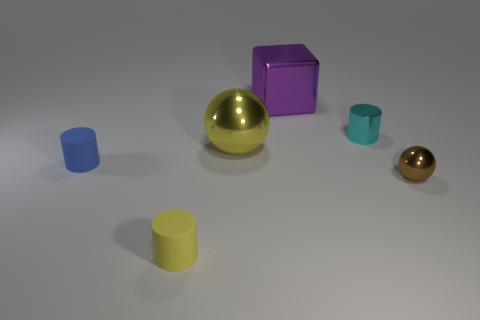There is a blue object that is the same shape as the yellow matte object; what material is it?
Provide a succinct answer. Rubber. The tiny metallic sphere is what color?
Make the answer very short. Brown. Do the small shiny cylinder and the metallic block have the same color?
Provide a short and direct response. No. What number of metal things are either small brown balls or large things?
Ensure brevity in your answer.  3. Is there a small rubber object that is to the right of the tiny rubber thing that is behind the matte thing that is in front of the brown shiny thing?
Your answer should be very brief. Yes. What is the size of the brown thing that is made of the same material as the cyan cylinder?
Your answer should be compact. Small. There is a cyan cylinder; are there any spheres in front of it?
Your answer should be very brief. Yes. There is a rubber thing in front of the tiny blue rubber thing; are there any purple metal things that are on the left side of it?
Offer a very short reply. No. There is a rubber cylinder in front of the small sphere; does it have the same size as the metal ball in front of the tiny blue matte cylinder?
Your answer should be very brief. Yes. How many tiny things are spheres or cyan cylinders?
Provide a short and direct response. 2. 